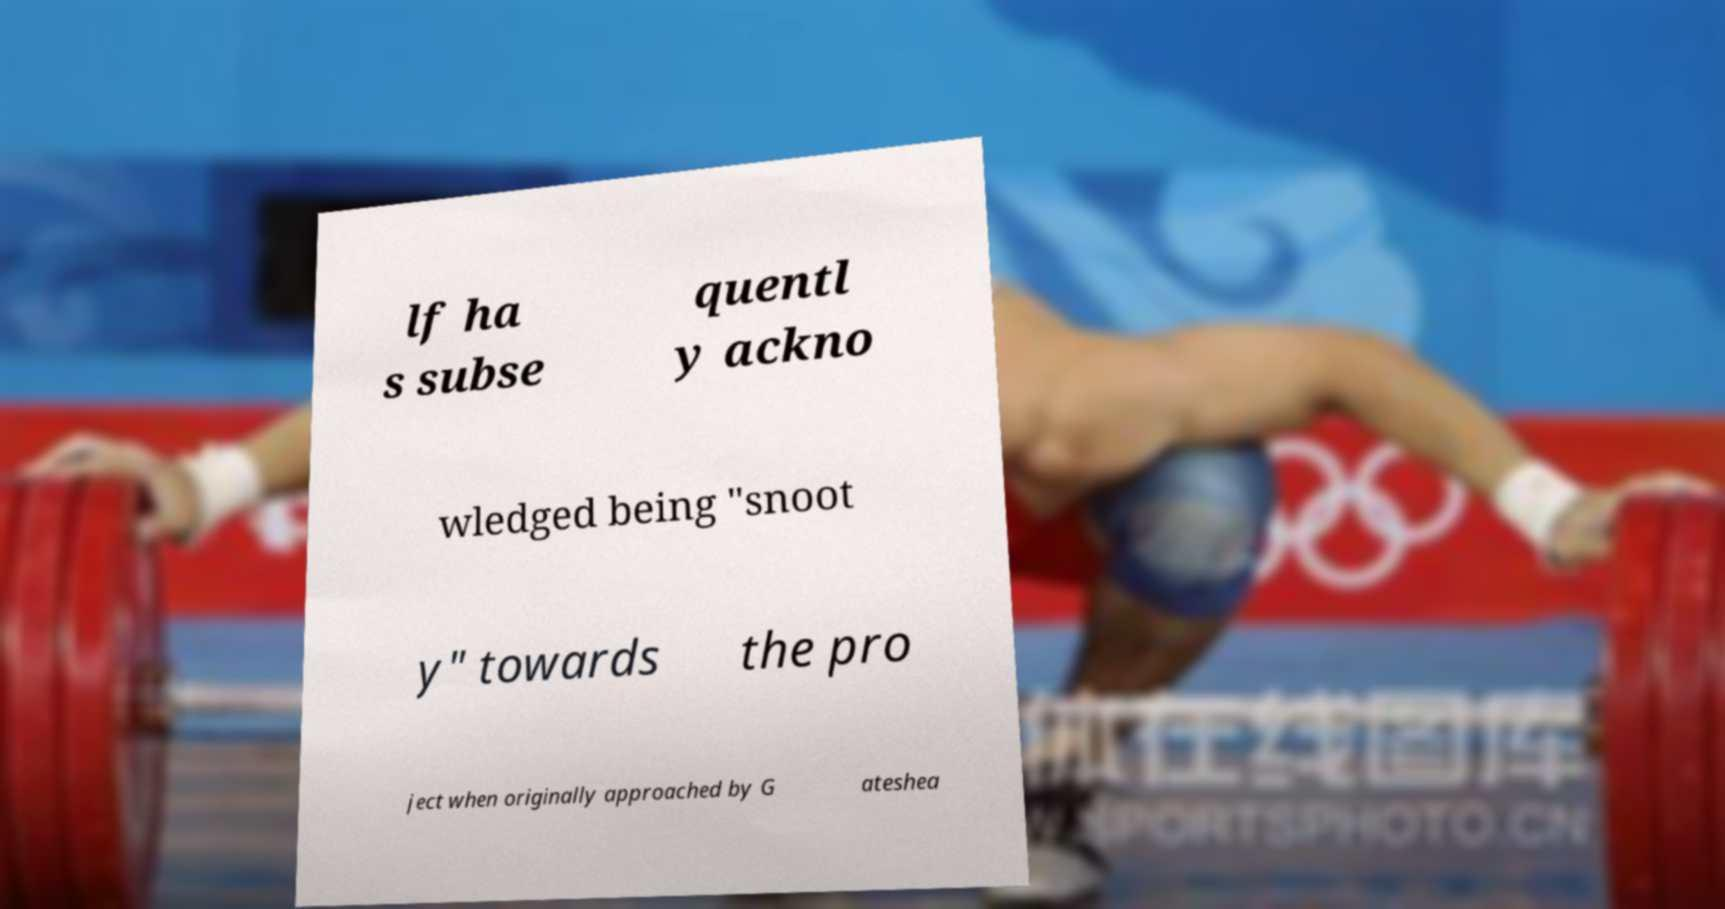Could you extract and type out the text from this image? lf ha s subse quentl y ackno wledged being "snoot y" towards the pro ject when originally approached by G ateshea 